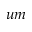<formula> <loc_0><loc_0><loc_500><loc_500>u m</formula> 